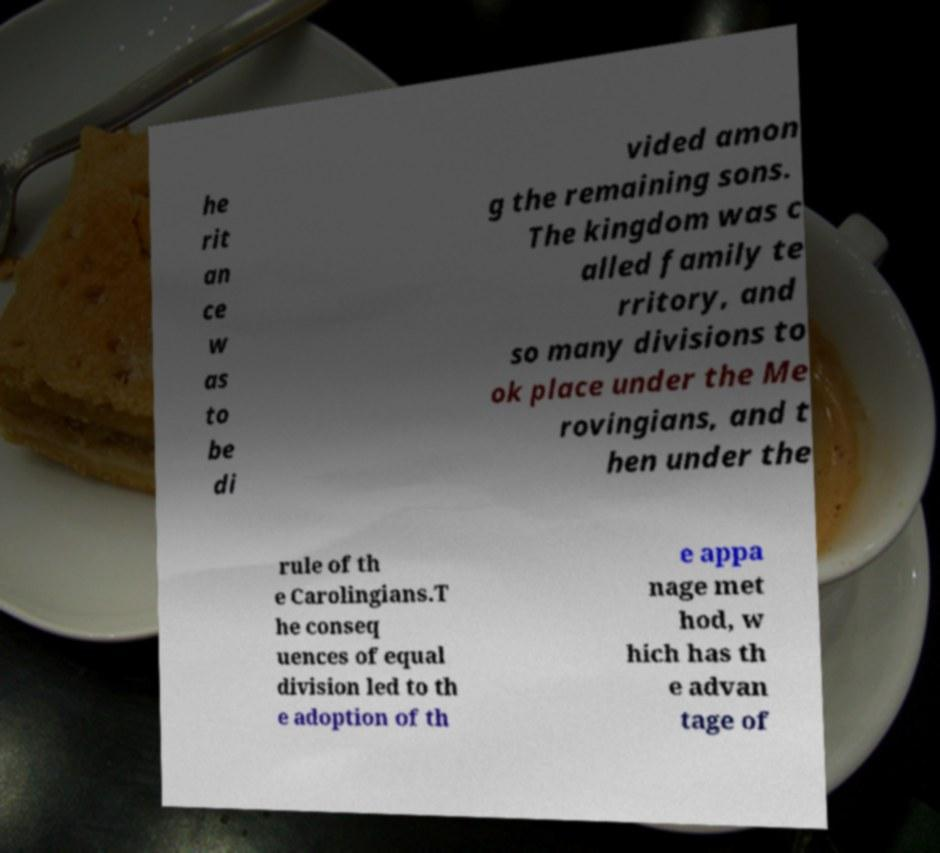Could you extract and type out the text from this image? he rit an ce w as to be di vided amon g the remaining sons. The kingdom was c alled family te rritory, and so many divisions to ok place under the Me rovingians, and t hen under the rule of th e Carolingians.T he conseq uences of equal division led to th e adoption of th e appa nage met hod, w hich has th e advan tage of 